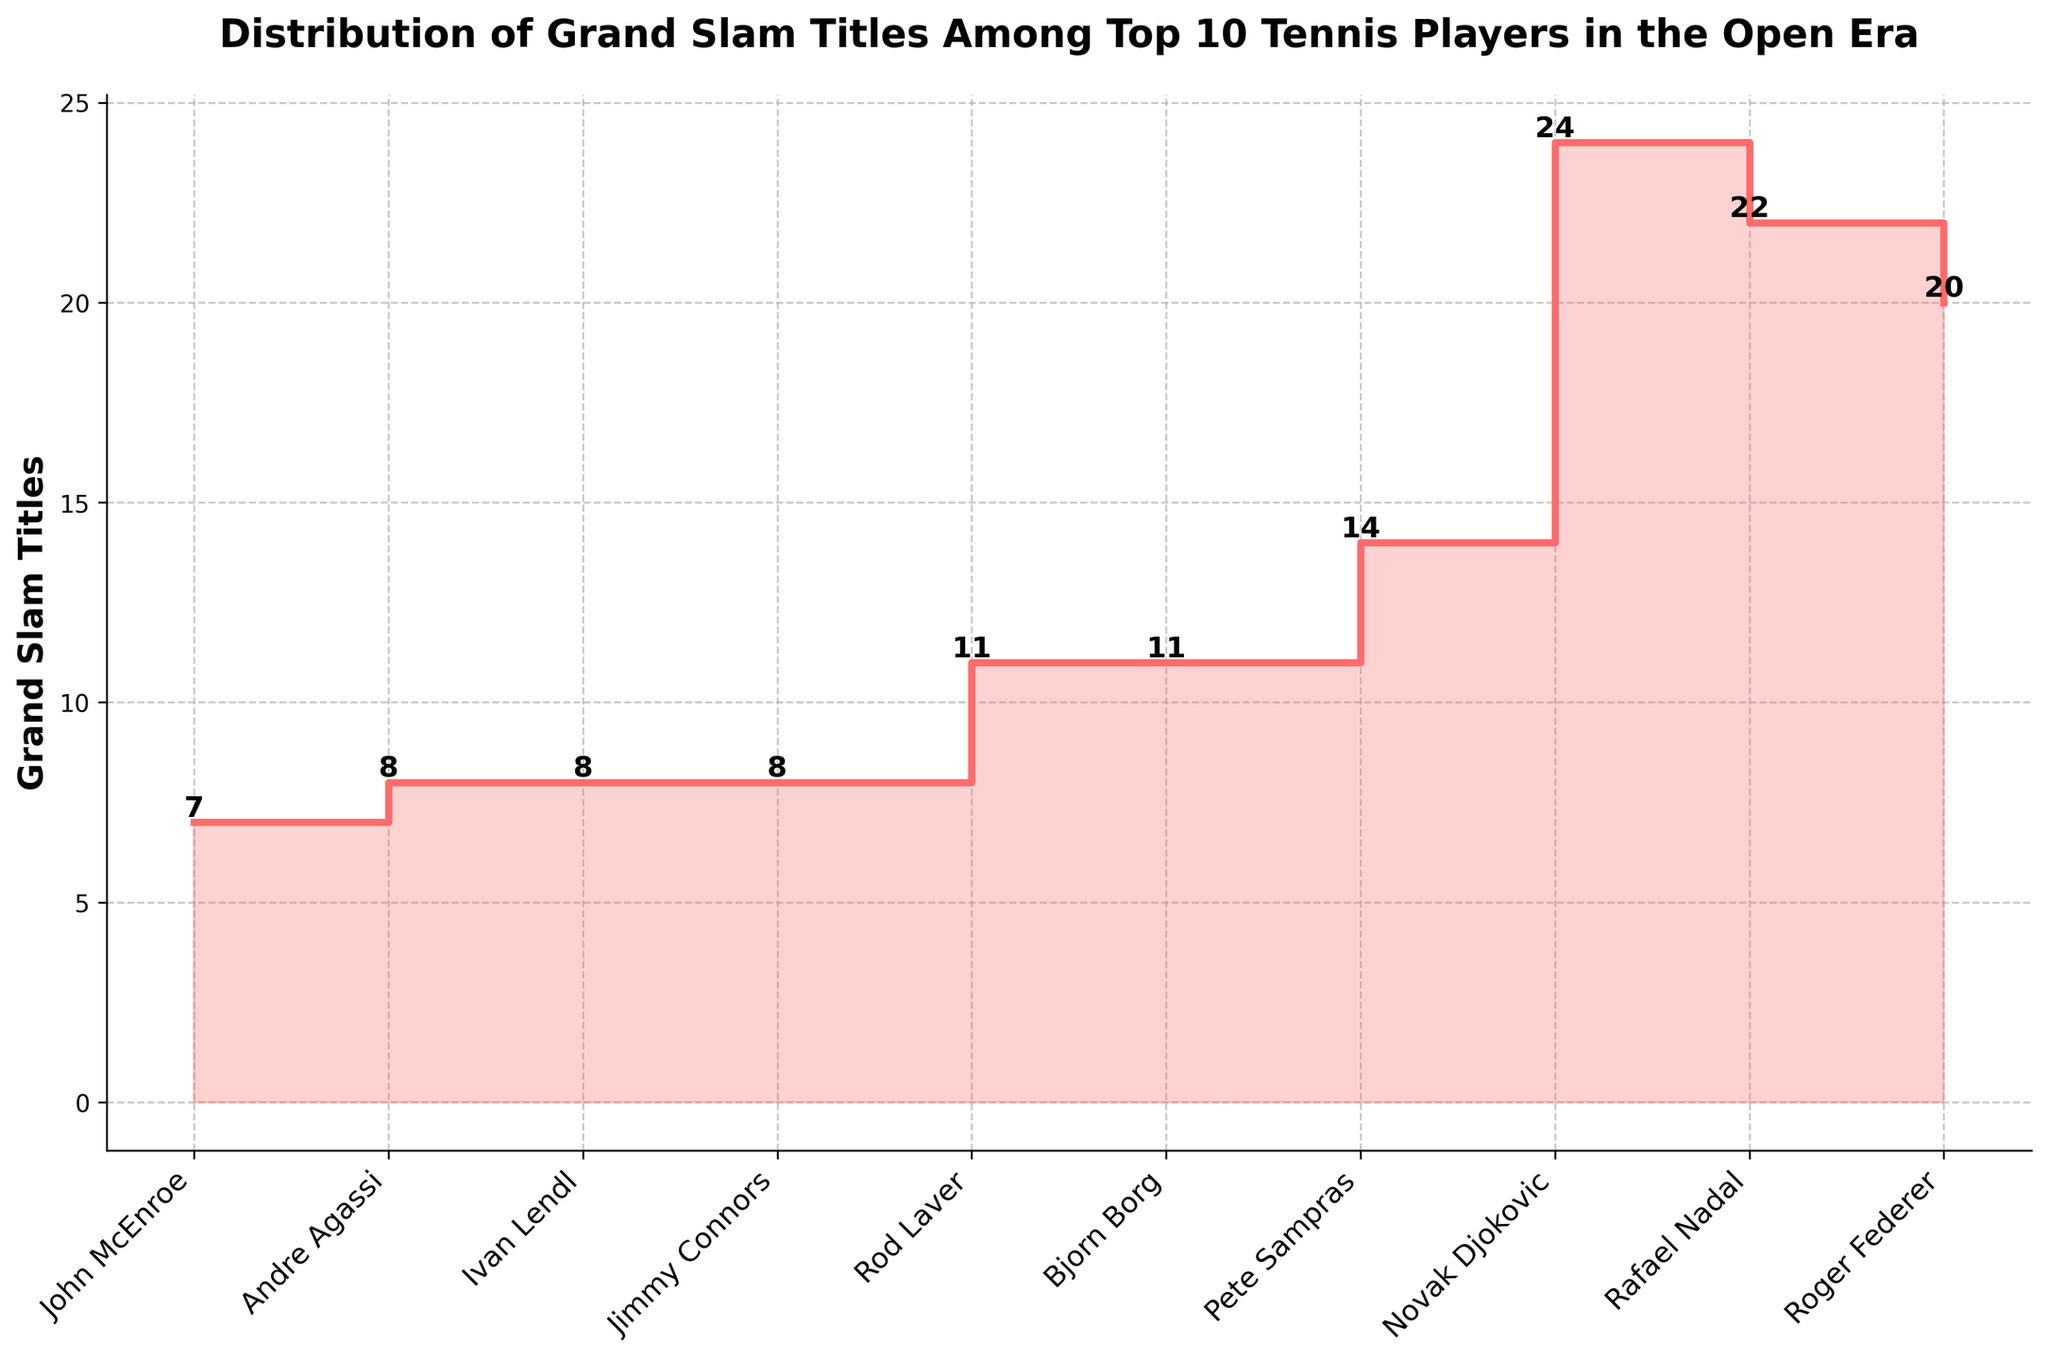What is the highest number of Grand Slam titles achieved by a player? By looking at the highest step on the chart, it is clear that Novak Djokovic holds the highest number of Grand Slam titles.
Answer: 24 Who are the players with exactly 8 Grand Slam titles? Observing the steps on the chart, you will find that Jimmy Connors, Ivan Lendl, and Andre Agassi each have 8 Grand Slam titles.
Answer: Jimmy Connors, Ivan Lendl, Andre Agassi What is the difference in Grand Slam titles between Rafael Nadal and Pete Sampras? According to the chart, Rafael Nadal has 22 titles and Pete Sampras has 14 titles. The difference is calculated as 22 - 14.
Answer: 8 How many players have 10 or more Grand Slam titles? Counting the number of players on the chart with steps at 10 or more titles, we find Roger Federer, Rafael Nadal, Novak Djokovic, Pete Sampras, Bjorn Borg, and Rod Laver.
Answer: 6 Which player is placed at the lowest step with 7 Grand Slam titles? Observing the lowest position on the chart, John McEnroe is the player with 7 Grand Slam titles.
Answer: John McEnroe What is the median number of Grand Slam titles among these top 10 players? Arranging the titles in ascending order (7, 8, 8, 8, 11, 11, 14, 20, 22, 24), the middle values are 11 and 11. The median is (11 + 11)/2.
Answer: 11 Which player has won more Grand Slam titles, Bjorn Borg or Rod Laver? Both Bjorn Borg and Rod Laver have a step at the same level, which indicates they each have the same number of Grand Slam titles.
Answer: Equal What is the average number of Grand Slam titles among the top 3 players? Adding the titles of Novak Djokovic (24), Rafael Nadal (22), and Roger Federer (20), we get 66. Dividing by 3 gives the average.
Answer: 22 How many titles do the bottom 5 players combined have? Summing the titles of Jimmy Connors (8), Ivan Lendl (8), Andre Agassi (8), John McEnroe (7), and Rod Laver (11) gives us 8 + 8 + 8 + 7 + 11.
Answer: 42 Which player has more Grand Slam titles, Novak Djokovic or the combined total of Jimmy Connors and Ivan Lendl? Novak Djokovic has 24 titles. Jimmy Connors and Ivan Lendl combined have 8 + 8, totaling 16. Comparing 24 and 16, Novak Djokovic has more.
Answer: Novak Djokovic 